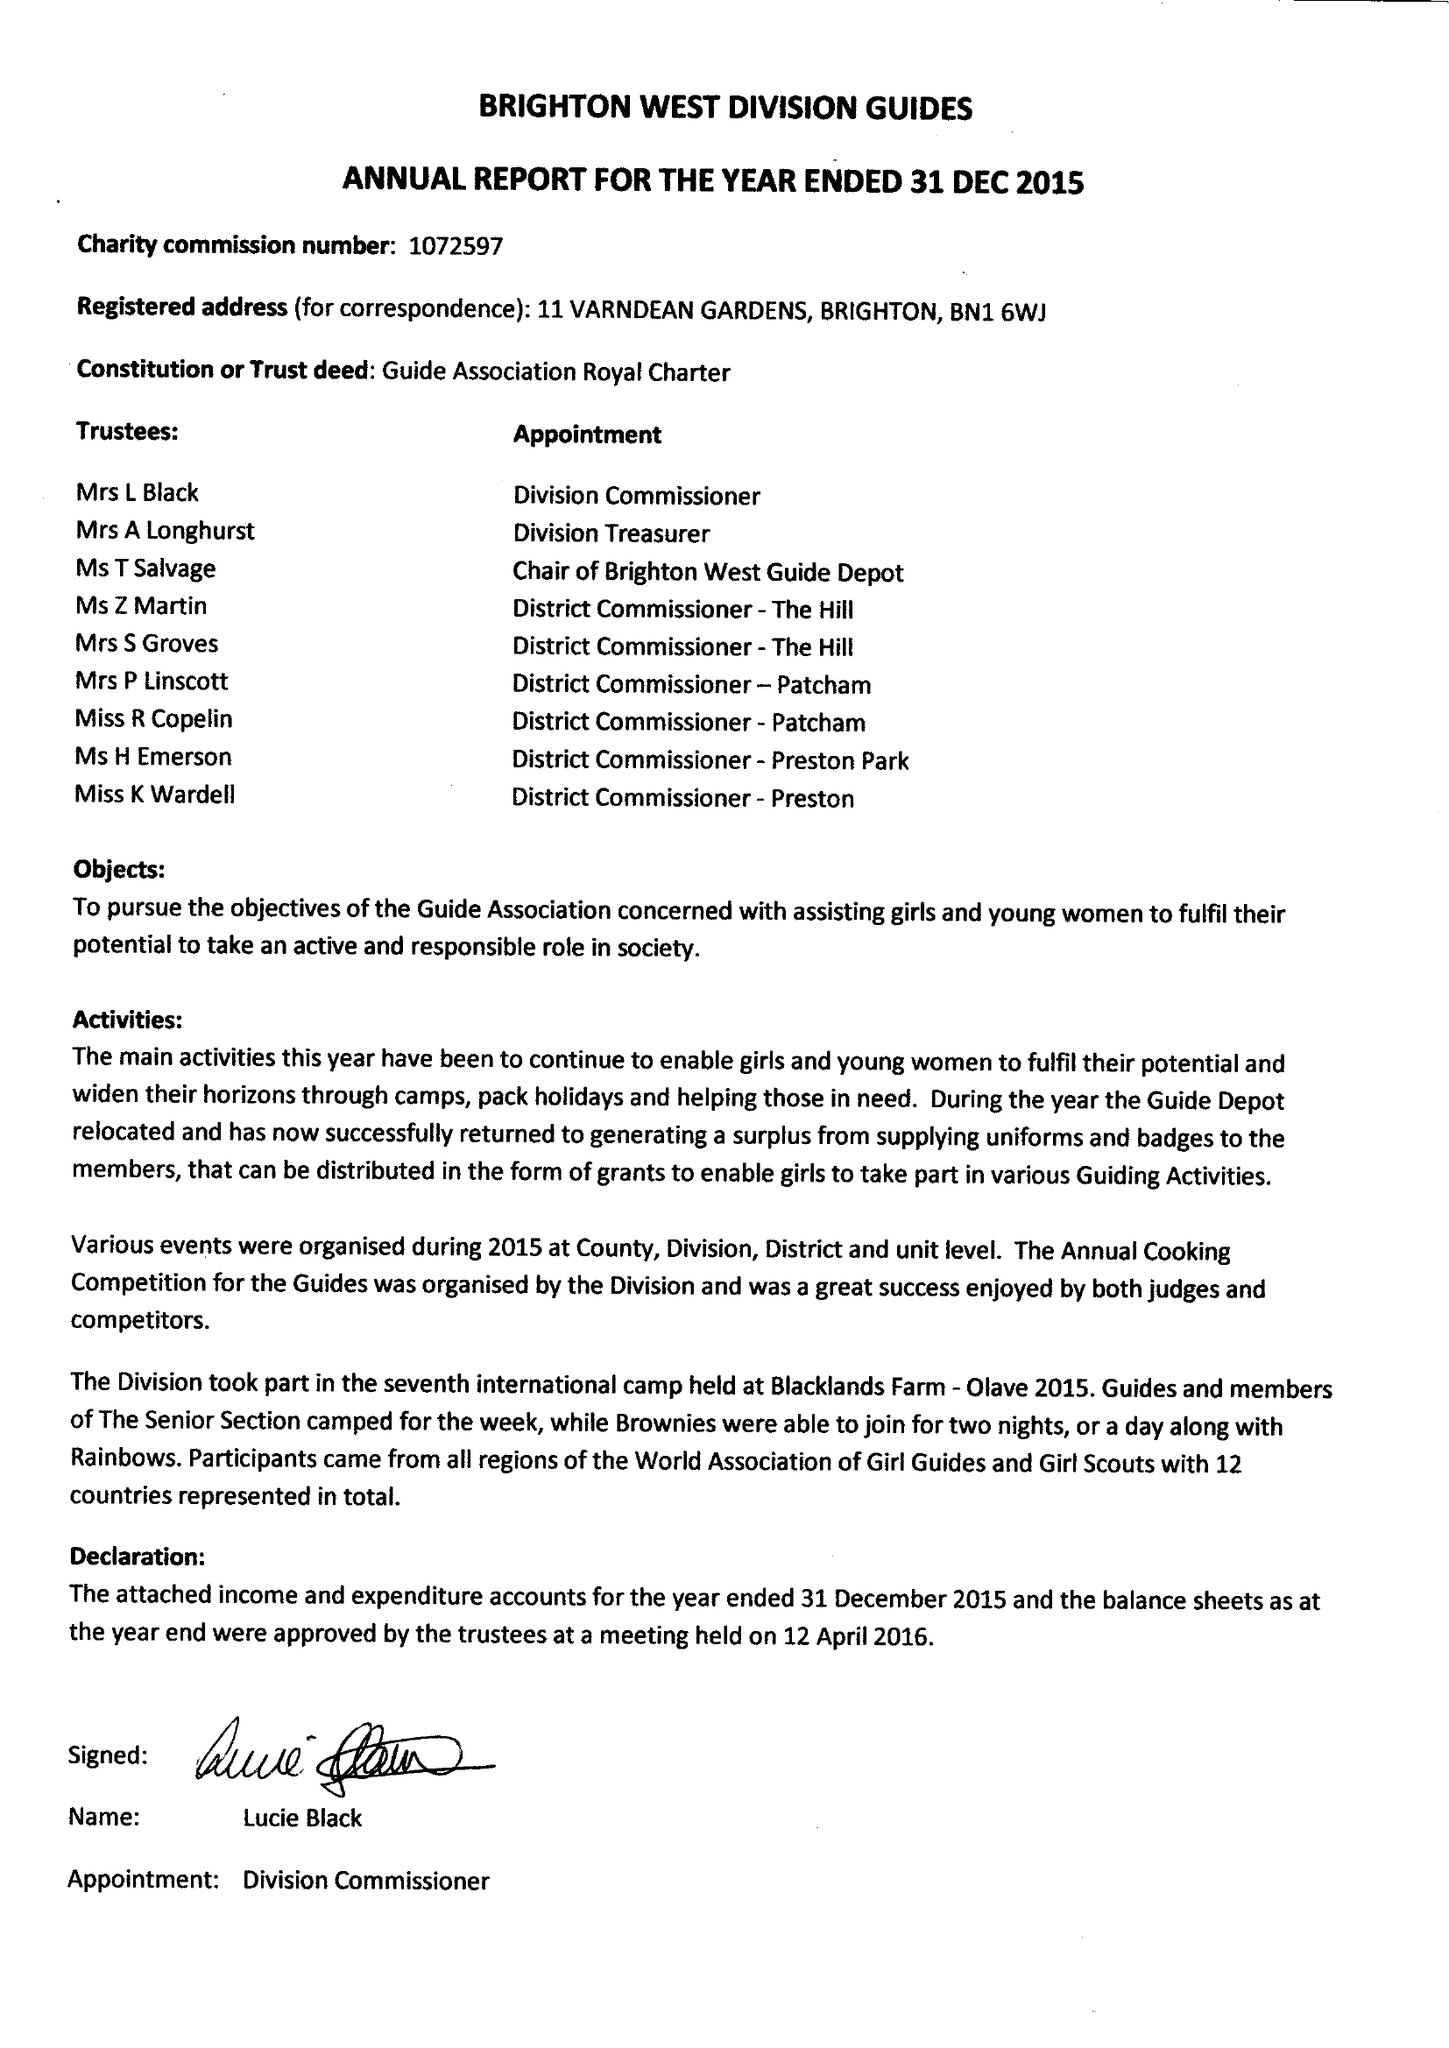What is the value for the report_date?
Answer the question using a single word or phrase. 2015-12-31 